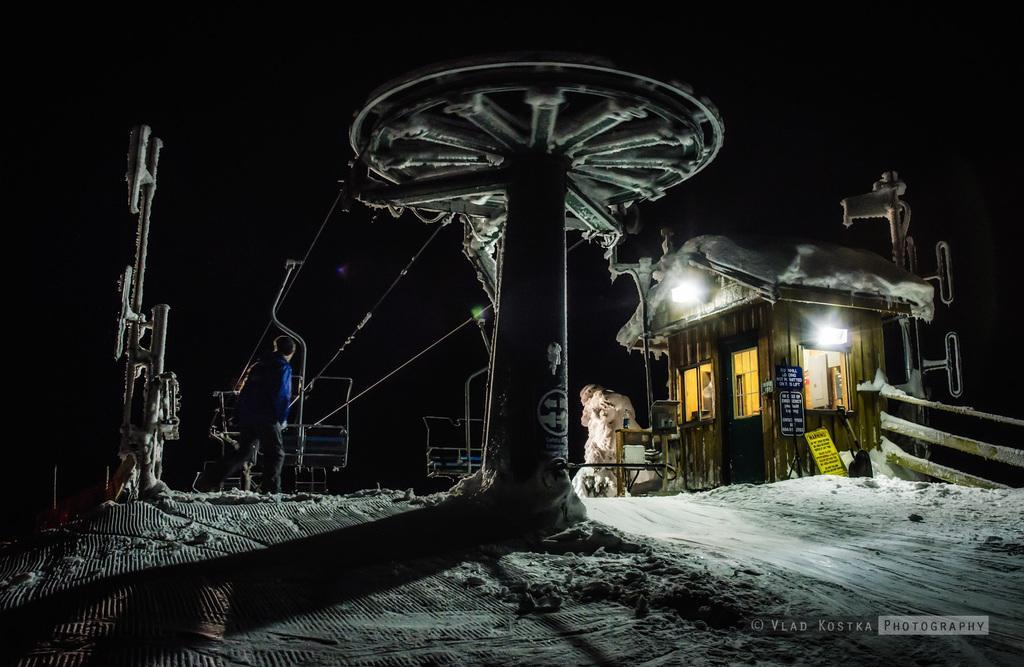Could you give a brief overview of what you see in this image? This image is taken outdoors. In this image the background is dark. At the bottom of the image there is a ground covered with snow. In the middle of the image there is a hut covered with snow. There are a few poles. There are a few boards with text on them. There is a cable car and a man is standing in the snow. 